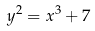Convert formula to latex. <formula><loc_0><loc_0><loc_500><loc_500>y ^ { 2 } = x ^ { 3 } + 7</formula> 